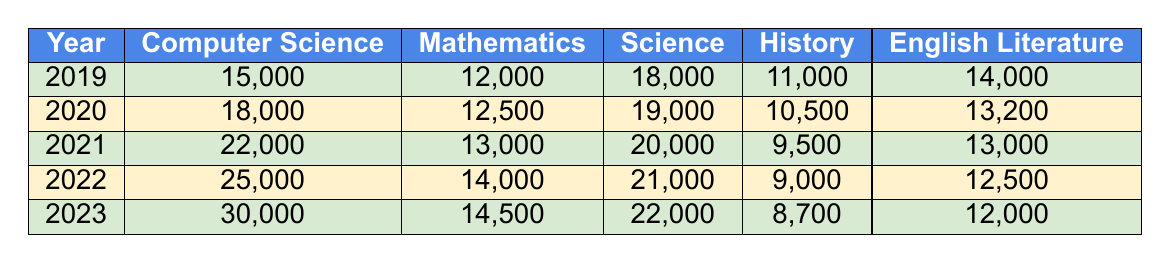What was the enrollment number for computer science in 2021? Referring directly to the 2021 row in the table, the enrollment number for computer science is 22,000.
Answer: 22,000 In which year did computer science see the highest enrollment? By examining the table, the highest enrollment in computer science occurred in 2023, with 30,000 students.
Answer: 2023 What is the difference in enrollment between computer science and mathematics in 2022? In 2022, the enrollment for computer science is 25,000 and for mathematics, it is 14,000. The difference is 25,000 - 14,000 = 11,000.
Answer: 11,000 Which subject had the lowest enrollment in 2019? Looking at the 2019 column, the enrollment numbers are 15,000 for computer science, 12,000 for mathematics, 18,000 for science, 11,000 for history, and 14,000 for English literature. The lowest number is 11,000 for history.
Answer: History What was the average enrollment for computer science over the last five years? The enrollment numbers for computer science over the five years are 15,000, 18,000, 22,000, 25,000, and 30,000. The total is 110,000, so the average is 110,000 / 5 = 22,000.
Answer: 22,000 Did the enrollment for history increase or decrease from 2020 to 2023? In 2020, the enrollment for history was 10,500, and in 2023 it was 8,700. As 8,700 is less than 10,500, it shows a decrease.
Answer: Decrease Which subject had a higher enrollment in 2022, English literature or science? The 2022 enrollment for English literature is 12,500, while for science it is 21,000. Since 21,000 is greater than 12,500, science had a higher enrollment.
Answer: Science What was the total enrollment for traditional subjects (mathematics, science, history, and English literature) in 2023? In 2023, the enrollment numbers are 14,500 for mathematics, 22,000 for science, 8,700 for history, and 12,000 for English literature. Adding these values gives 14,500 + 22,000 + 8,700 + 12,000 = 57,200.
Answer: 57,200 Which subject's enrollment grew the fastest between 2019 and 2023? The growth for each subject is calculated by subtracting the 2019 number from the 2023 number: CS (30,000 - 15,000 = 15,000), Math (14,500 - 12,000 = 2,500), Science (22,000 - 18,000 = 4,000), History (8,700 - 11,000 = -2,300), English (12,000 - 14,000 = -2,000). The fastest growth is 15,000 for computer science.
Answer: Computer Science Is there any year where the enrollment in science was lower than that in computer science? By examining the table, the numbers for science (18,000, 19,000, 20,000, 21,000, 22,000) were always higher than those for computer science in 2019 (15,000) and 2020 (18,000). Hence, there was a year where it was lower.
Answer: Yes 